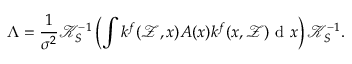<formula> <loc_0><loc_0><loc_500><loc_500>\Lambda = \frac { 1 } { \sigma ^ { 2 } } \mathcal { K } _ { S } ^ { - 1 } \left ( \int k ^ { f } ( \mathcal { Z } , x ) A ( x ) k ^ { f } ( x , \mathcal { Z } ) d x \right ) \mathcal { K } _ { S } ^ { - 1 } .</formula> 